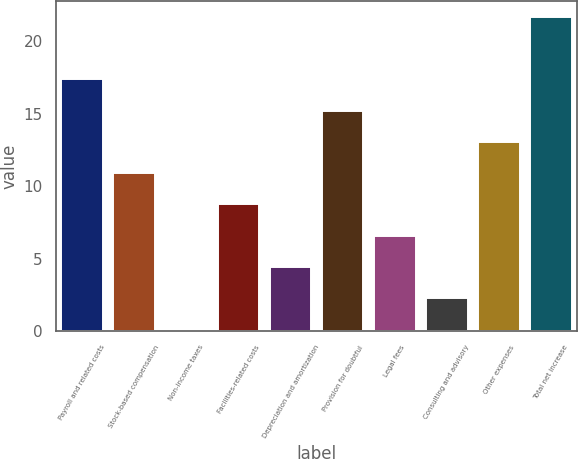<chart> <loc_0><loc_0><loc_500><loc_500><bar_chart><fcel>Payroll and related costs<fcel>Stock-based compensation<fcel>Non-income taxes<fcel>Facilities-related costs<fcel>Depreciation and amortization<fcel>Provision for doubtful<fcel>Legal fees<fcel>Consulting and advisory<fcel>Other expenses<fcel>Total net increase<nl><fcel>17.38<fcel>10.9<fcel>0.1<fcel>8.74<fcel>4.42<fcel>15.22<fcel>6.58<fcel>2.26<fcel>13.06<fcel>21.7<nl></chart> 